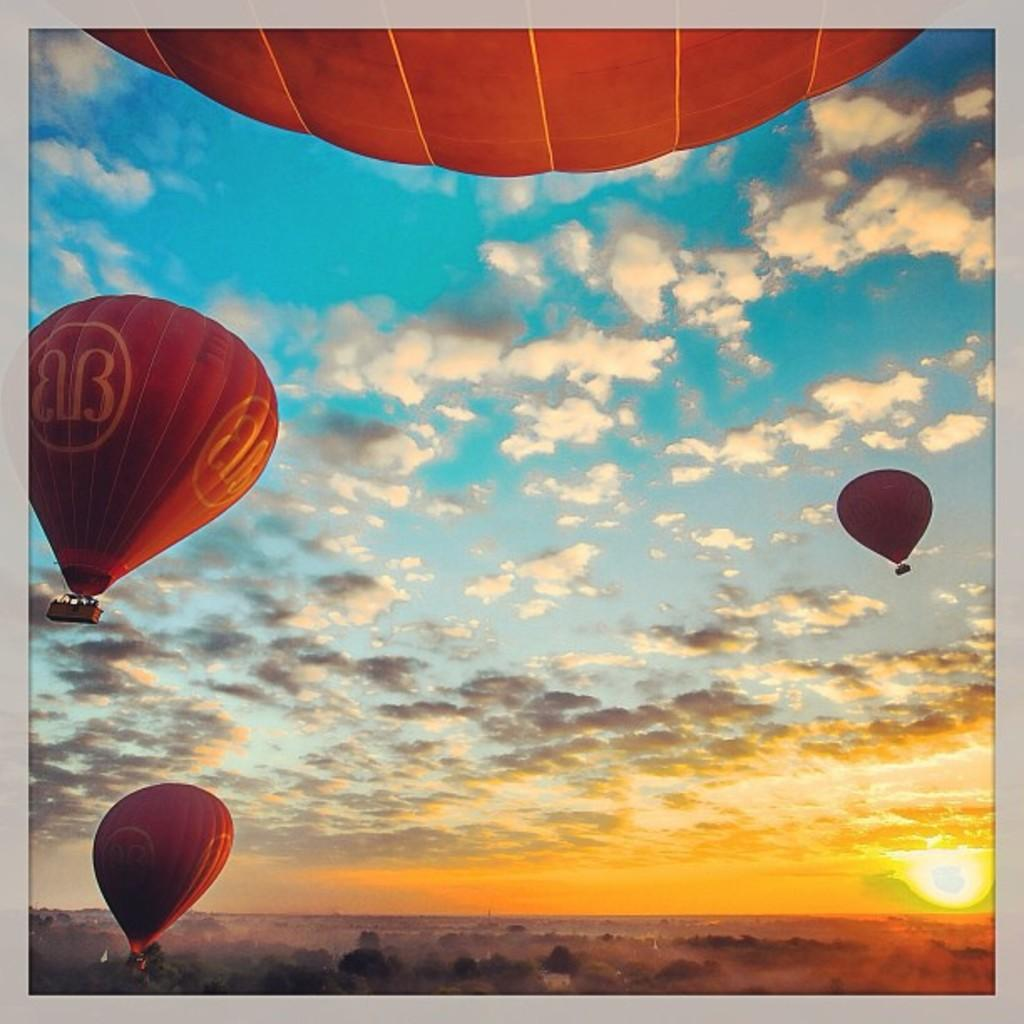What is in the air in the image? There are hot air balloons in the air. What type of vegetation can be seen in the image? There are trees visible in the image. What is the condition of the sky in the background? The sky is cloudy in the background. Where is the son sitting at his desk in the image? There is no son or desk present in the image; it features hot air balloons and trees. Can you see a rifle in the image? There is no rifle present in the image. 